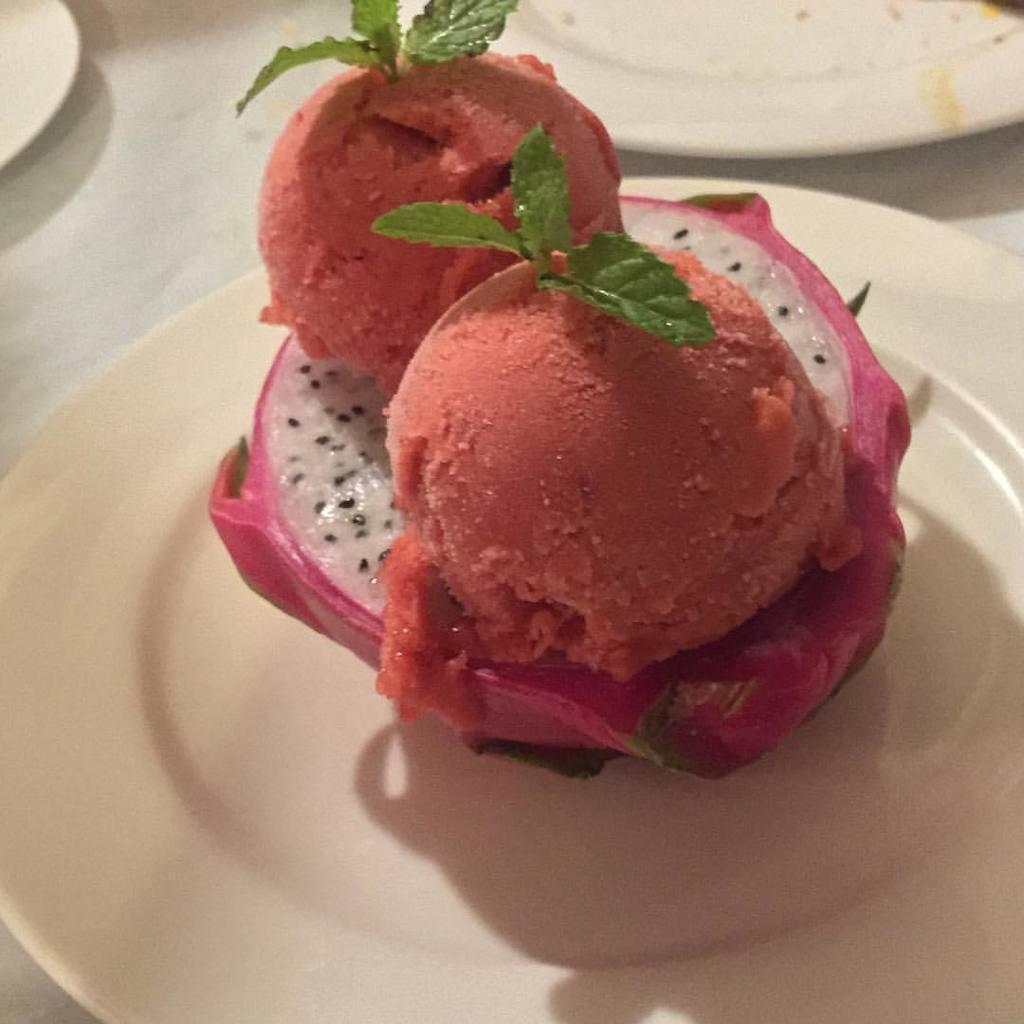What type of fruit is in the image? There is a fruit in the image, but the specific type of fruit is not mentioned. What else is present in the image besides the fruit? There are food items in the image. How are the fruit and food items arranged in the image? The fruit and food items are in a plate. Where are the plates located in the image? There are plates on a table in the image. What type of hose is used to water the fruit in the image? There is no hose present in the image, and the fruit is not being watered. What muscle is being exercised by the fruit in the image? The fruit is not a muscle, and therefore it is not exercising any muscles. 